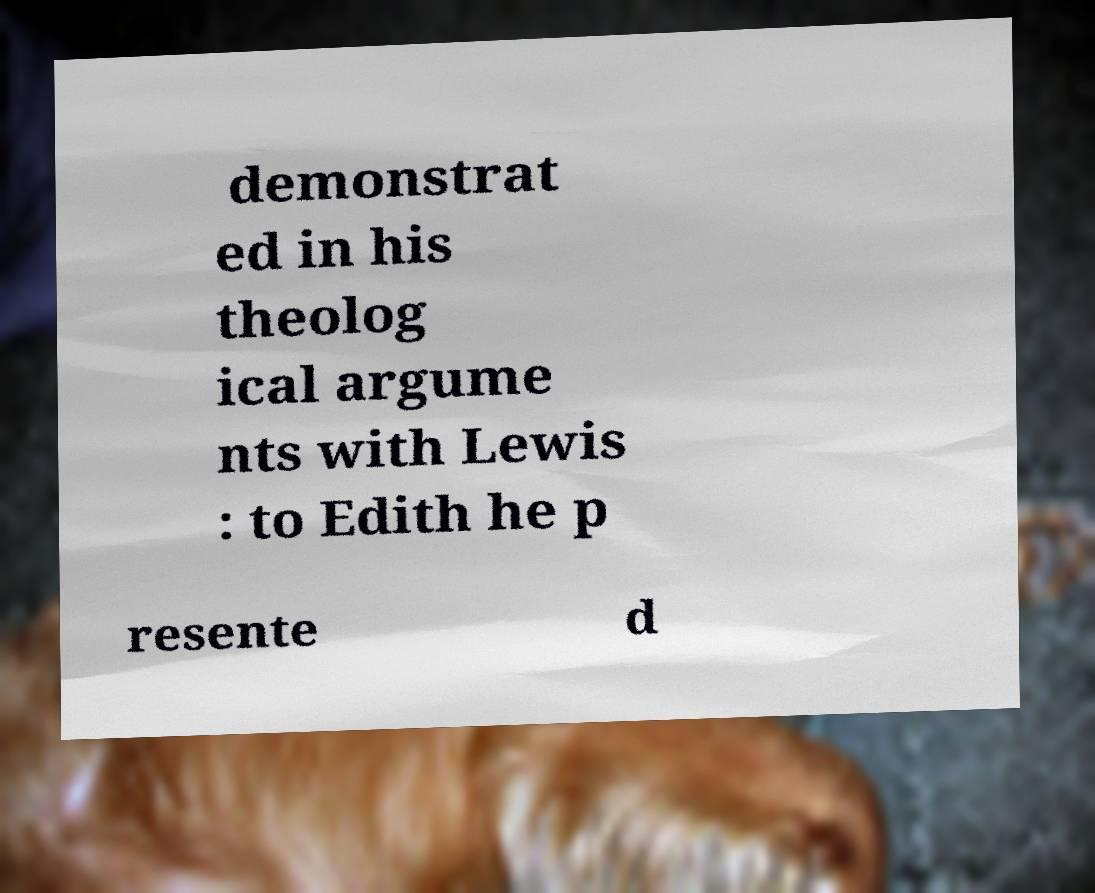There's text embedded in this image that I need extracted. Can you transcribe it verbatim? demonstrat ed in his theolog ical argume nts with Lewis : to Edith he p resente d 